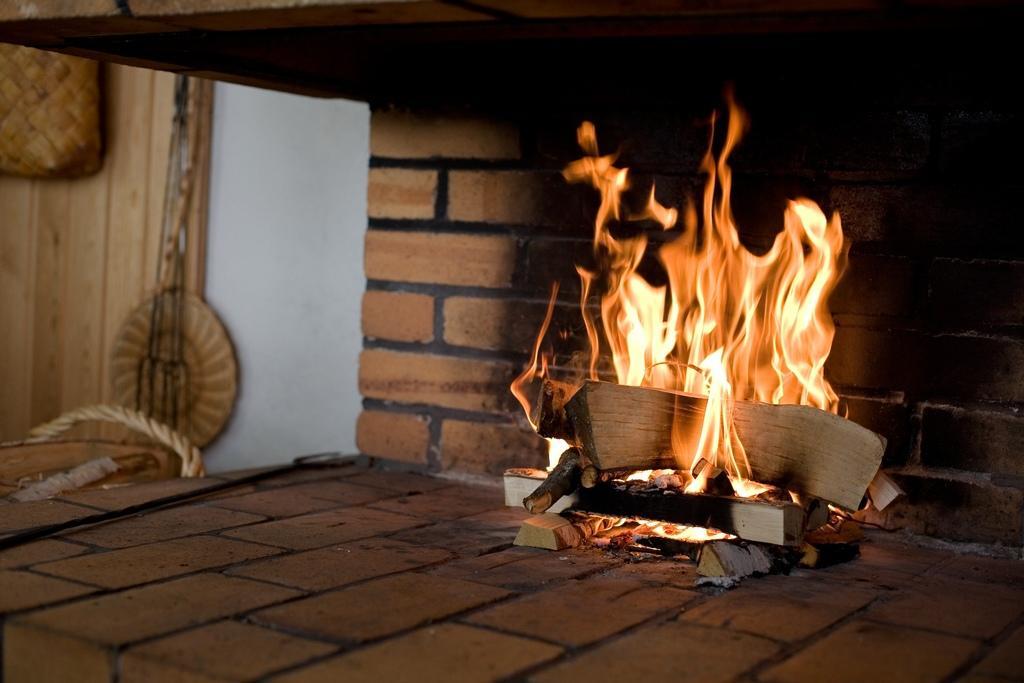Please provide a concise description of this image. In this image we can see some wooden pieces burning. There is fire. In the back there is a brick wall. On the left side there is a rope and some other objects. 